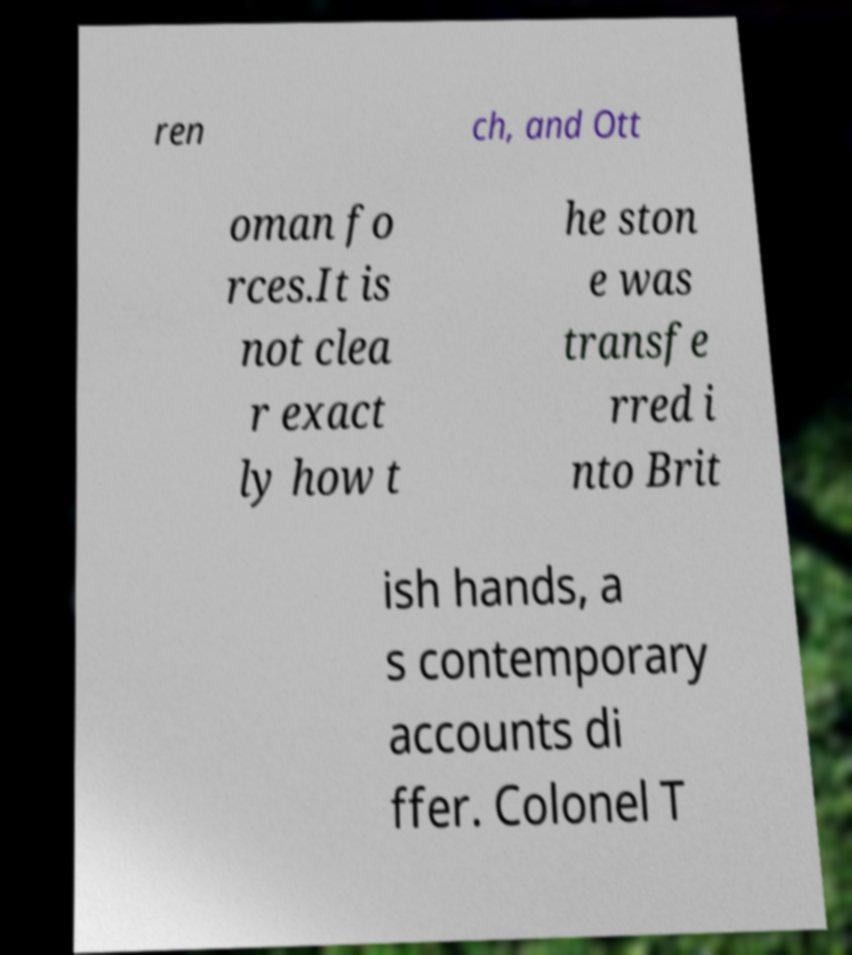There's text embedded in this image that I need extracted. Can you transcribe it verbatim? ren ch, and Ott oman fo rces.It is not clea r exact ly how t he ston e was transfe rred i nto Brit ish hands, a s contemporary accounts di ffer. Colonel T 